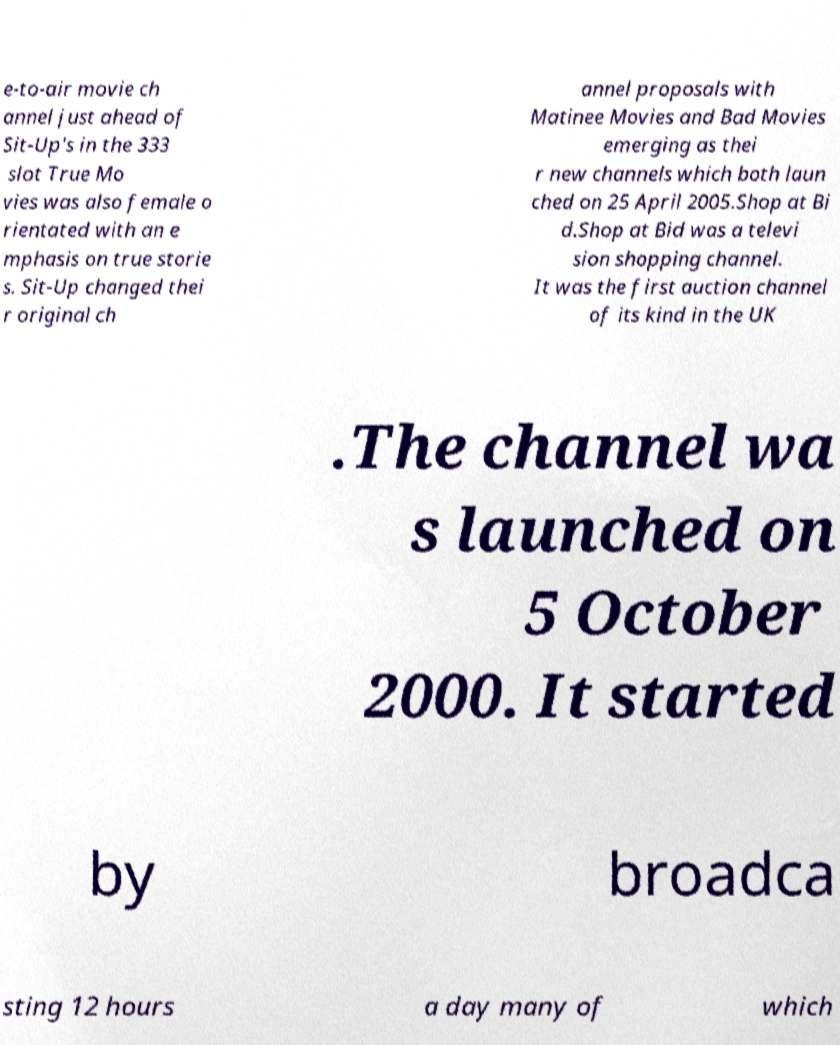Could you assist in decoding the text presented in this image and type it out clearly? e-to-air movie ch annel just ahead of Sit-Up's in the 333 slot True Mo vies was also female o rientated with an e mphasis on true storie s. Sit-Up changed thei r original ch annel proposals with Matinee Movies and Bad Movies emerging as thei r new channels which both laun ched on 25 April 2005.Shop at Bi d.Shop at Bid was a televi sion shopping channel. It was the first auction channel of its kind in the UK .The channel wa s launched on 5 October 2000. It started by broadca sting 12 hours a day many of which 